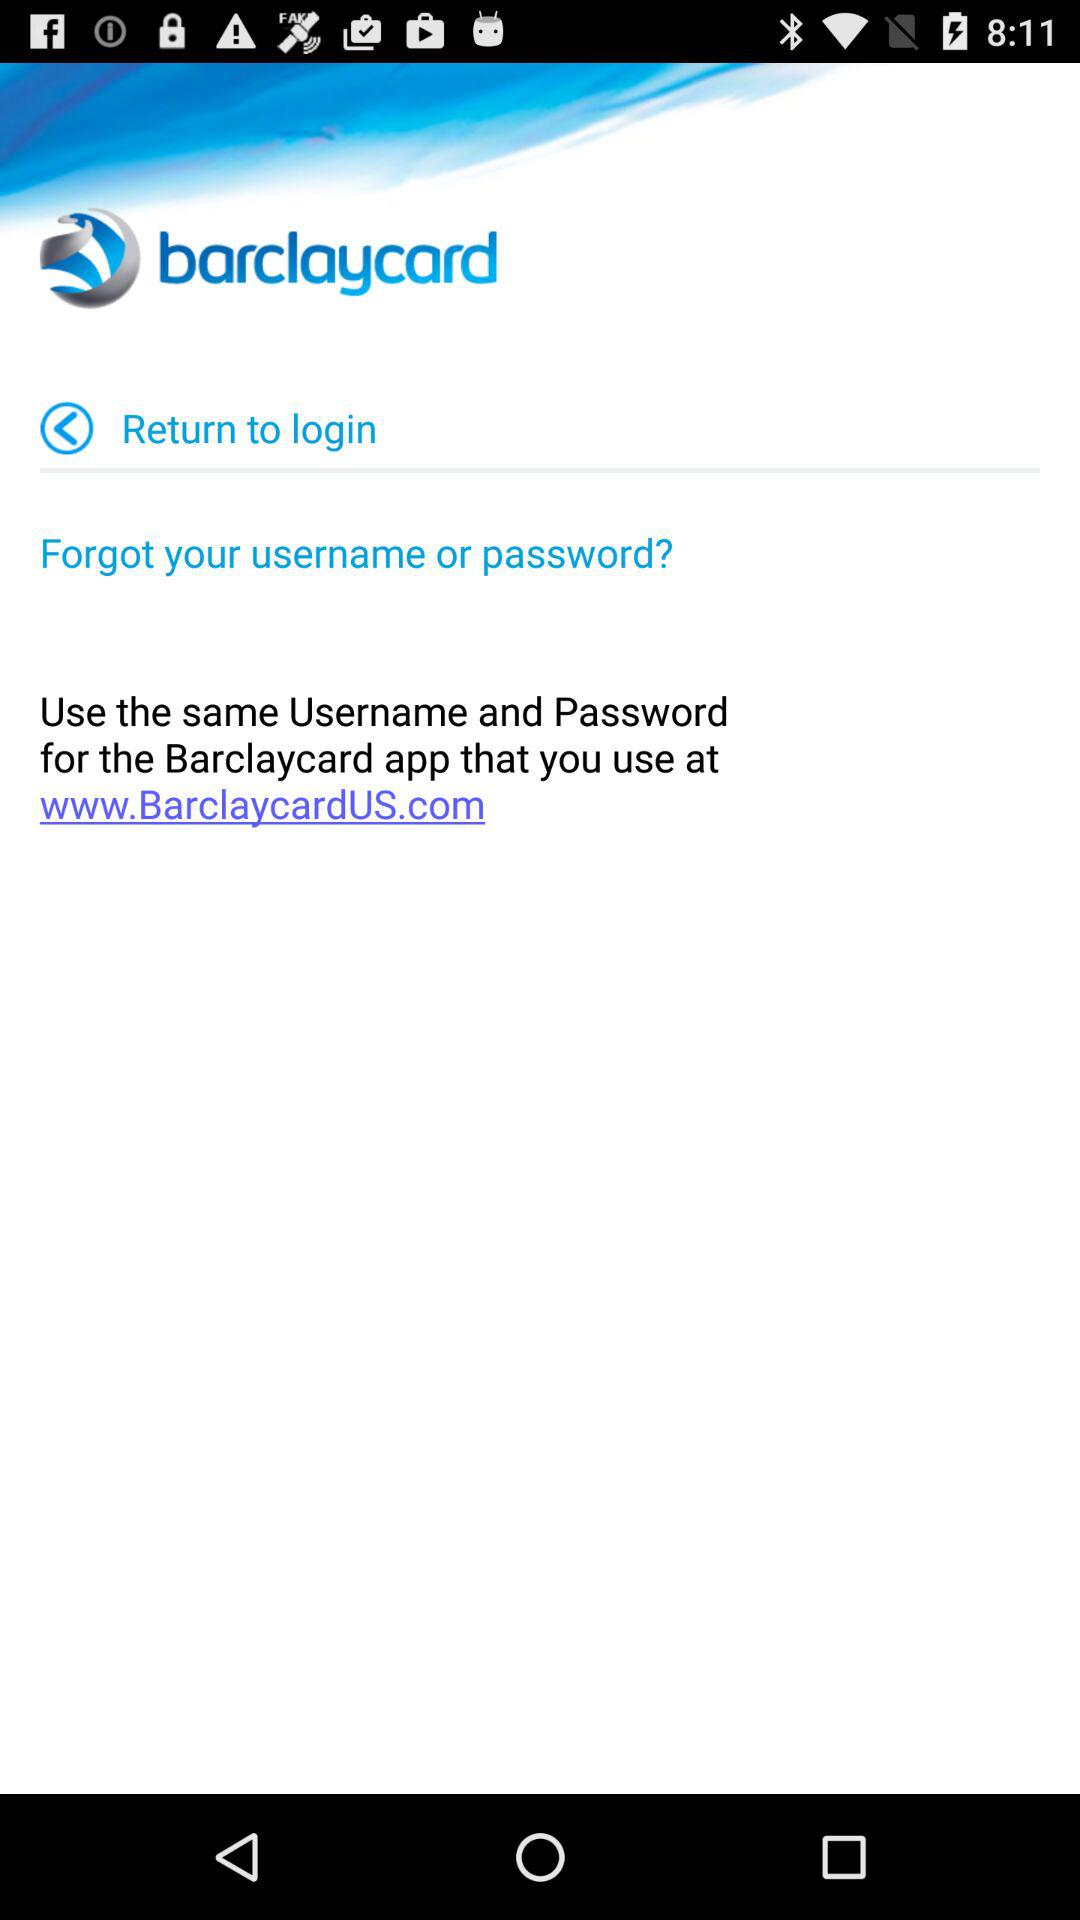What is the URL Address of the app? The URL address is "www.BarclaycardUs.com". 